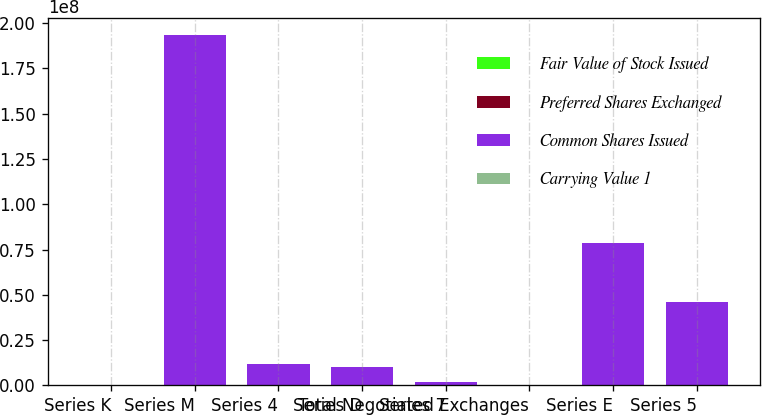<chart> <loc_0><loc_0><loc_500><loc_500><stacked_bar_chart><ecel><fcel>Series K<fcel>Series M<fcel>Series 4<fcel>Series D<fcel>Series 7<fcel>Total Negotiated Exchanges<fcel>Series E<fcel>Series 5<nl><fcel>Fair Value of Stock Issued<fcel>173298<fcel>102643<fcel>7024<fcel>6566<fcel>33404<fcel>322935<fcel>61509<fcel>29810<nl><fcel>Preferred Shares Exchanged<fcel>4332<fcel>2566<fcel>211<fcel>164<fcel>33<fcel>7306<fcel>1538<fcel>894<nl><fcel>Common Shares Issued<fcel>6323.5<fcel>1.9297e+08<fcel>1.16422e+07<fcel>1.01048e+07<fcel>2.06905e+06<fcel>6323.5<fcel>7.86705e+07<fcel>4.57535e+07<nl><fcel>Carrying Value 1<fcel>3635<fcel>2178<fcel>131<fcel>114<fcel>23<fcel>6081<fcel>1003<fcel>583<nl></chart> 